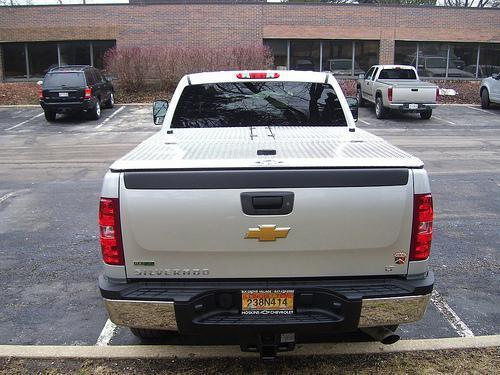How many vehicles are shown?
Give a very brief answer. 4. 